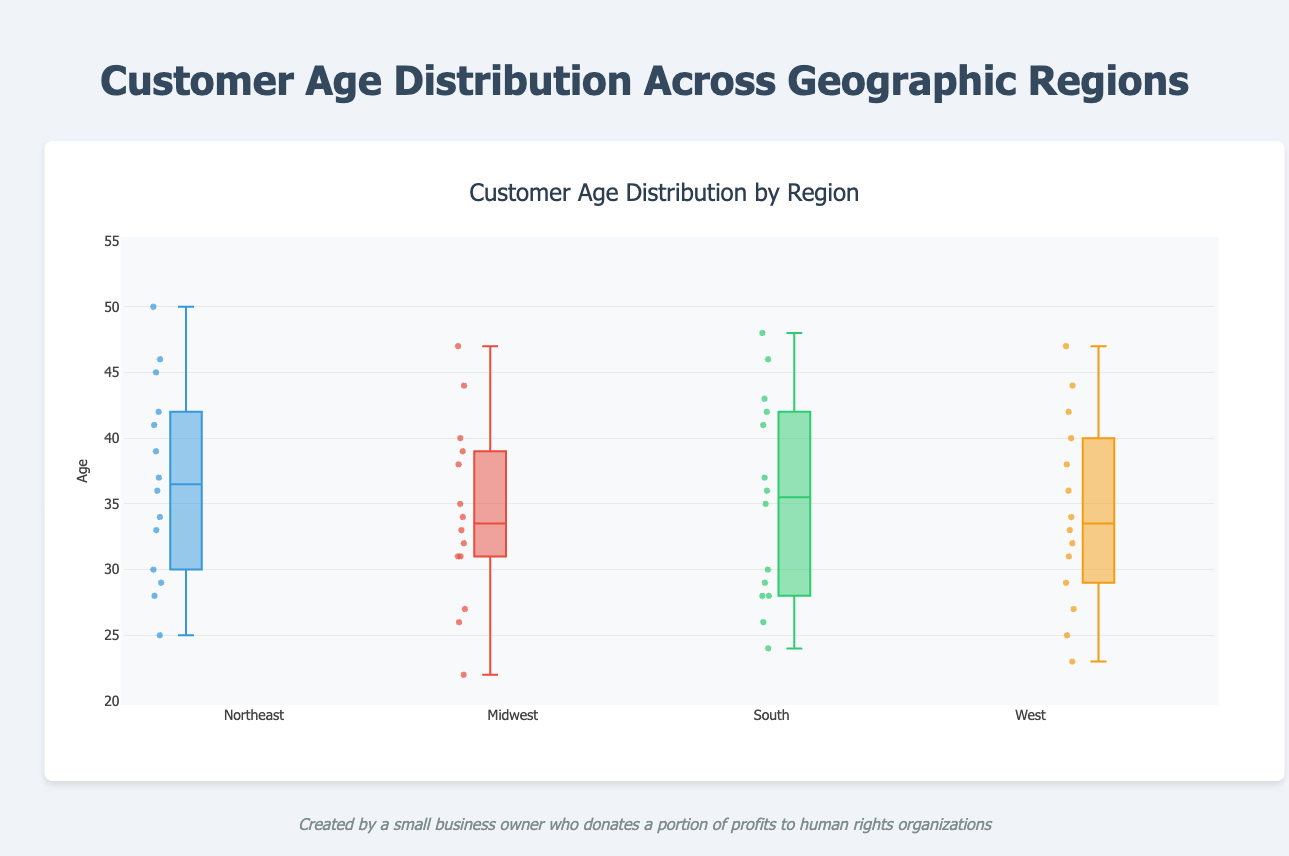How many geographic regions are shown in the box plot? Each box plot represents a different geographic region. By counting the distinct box plots, we find there are four: Northeast, Midwest, South, and West.
Answer: 4 What is the median customer age in the Northeast? The median age is indicated by the central line within the box for the Northeast plot.
Answer: 36 Which region has the highest single customer age? By examining the uppermost points on each plot, the highest appears in the Northeast region with an age of 50.
Answer: Northeast What is the interquartile range (IQR) for the Midwest? The IQR is computed by subtracting the first quartile (Q1) from the third quartile (Q3). Refer to the box edges in the Midwest plot: Q3 is around 39, and Q1 is around 31, so IQR = 39 - 31.
Answer: 8 How does the median age in the West compare to the median age in the South? The median age is shown by the central line in each box. The median age in the West is slightly lower than in the South.
Answer: West median is lower than South median Which region has the smallest range in customer ages? The range is the difference between the maximum and minimum ages depicted by the whiskers. The South has the smallest range from about 24 to 48.
Answer: South What is the maximum customer age in the Midwest? The maximum age is represented by the upper whisker endpoint in the Midwest plot and it reaches up to 47.
Answer: 47 Which region has the most tightly clustered age distribution? Compare the length of the boxes, which represent the IQR. The Midwest's box is the shortest, indicating the tightest clustering of ages around the median.
Answer: Midwest What is the most frequently occurring type of data points shown on each box plot? Jittered points within each box plot represent individual ages, revealing clusters of ages around the median values.
Answer: Individual customer ages How does the Midwest's upper quartile (Q3) customer age compare to the Northeast's median age? Identify the upper quartile (Q3) for the Midwest, which is around 39, and compare it to the median line of the Northeast, also around 36. Q3 in Midwest is higher than Northeast's median.
Answer: Midwest's Q3 is higher than Northeast's median 